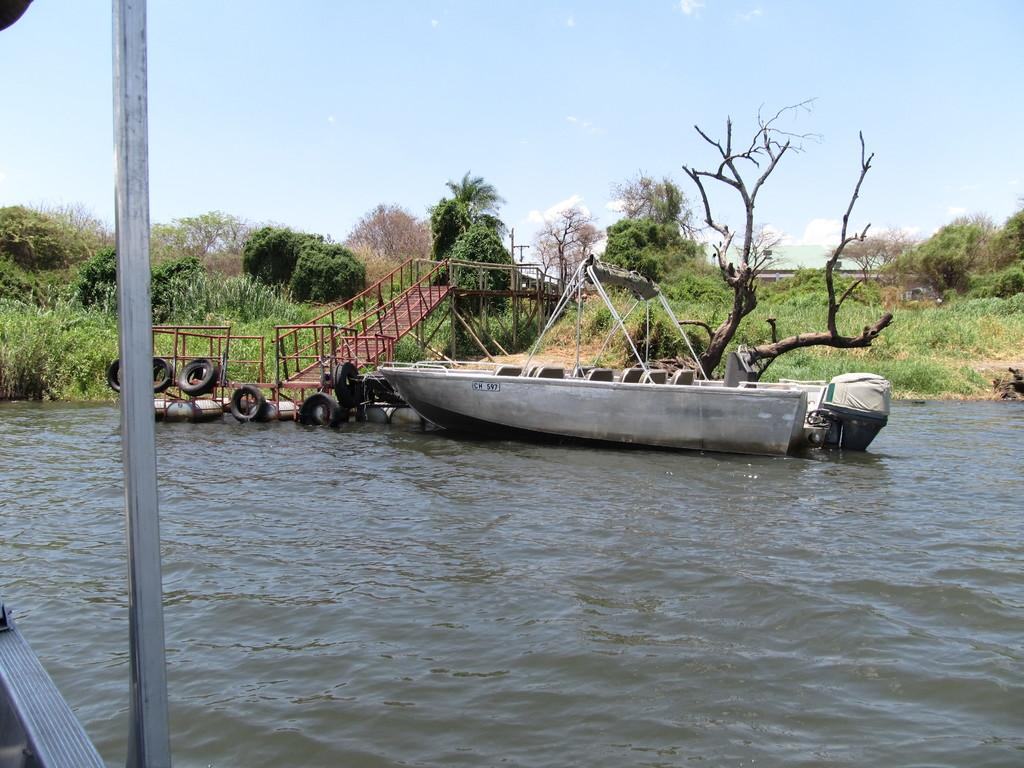What is in the water in the image? There is a boat in the water in the image. What can be seen near the boat? There are iron stairs beside the boat. What type of vegetation is visible in the image? There are trees on the ground in the image. How much tax is being paid for the boat in the image? There is no information about taxes in the image, so it cannot be determined. 